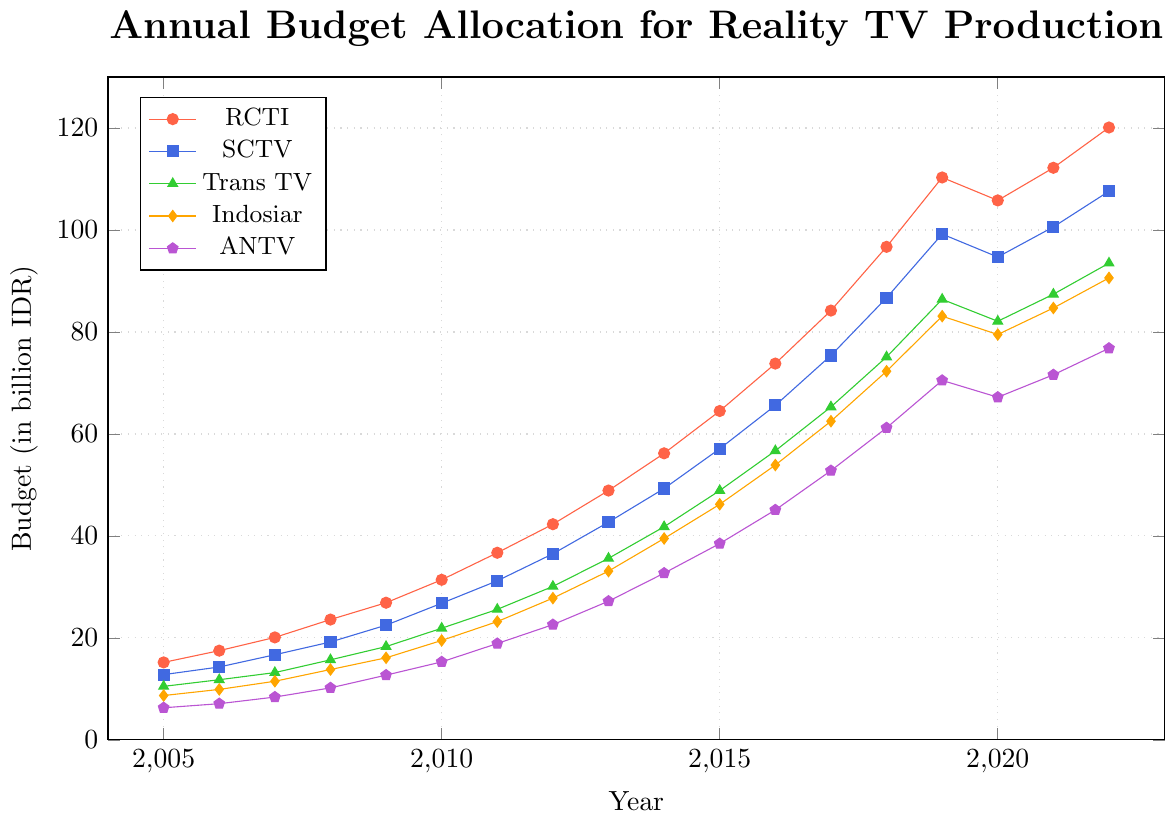What is the annual budget allocation for RCTI in 2020? To find the budget allocation for RCTI in 2020, look at the intersection of the RCTI line (red) and the year 2020 on the x-axis. The corresponding value on the y-axis is the budget.
Answer: 105.8 Between 2005 and 2022, which network had the highest increase in budget allocation? To find the highest increase, calculate the difference between the budget in 2022 and 2005 for each network and compare. RCTI increased from 15.2 to 120.1 (120.1 - 15.2 = 104.9), SCTV from 12.8 to 107.6 (107.6 - 12.8 = 94.8), Trans TV from 10.5 to 93.5 (93.5 - 10.5 = 83), Indosiar from 8.7 to 90.6 (90.6 - 8.7 = 81.9), ANTV from 6.3 to 76.8 (76.8 - 6.3 = 70.5). RCTI had the highest increase.
Answer: RCTI Which network had the lowest budget allocation in 2007? To find the network with the lowest budget in 2007, compare the budget values for each network at the year 2007 on the x-axis. RCTI (20.1), SCTV (16.7), Trans TV (13.2), Indosiar (11.5), ANTV (8.4). ANTV has the lowest value.
Answer: ANTV How does the budget allocation for Trans TV in 2019 compare to that in 2018? Find the budget allocation for Trans TV in 2019 and 2018 and compute their difference. In 2019, it is 86.4, and in 2018, it is 75.1. The difference is 86.4 - 75.1 = 11.3, meaning it increased by 11.3.
Answer: Increased by 11.3 What is the average annual budget allocation for SCTV from 2015 to 2020? To find the average, sum the budget allocations for SCTV from 2015 to 2020 and divide by the number of years. 57.1 (2015) + 65.6 (2016) + 75.4 (2017) + 86.7 (2018) + 99.2 (2019) + 94.7 (2020) = 478.7. The average is 478.7 / 6 = 79.78.
Answer: 79.78 Between which consecutive years did RCTI see the largest increase in budget? To determine the largest increase, calculate the year-to-year increase for RCTI and compare. Significant increases: 2007-2008 (23.6 - 20.1 = 3.5), 2008-2009 (26.9 - 23.6 = 3.3), 2016-2017 (84.2 - 73.8 = 10.4), 2017-2018 (96.7 - 84.2 = 12.5), 2018-2019 (110.3 - 96.7 = 13.6). The largest increase is between 2018 and 2019.
Answer: 2018-2019 Which year saw the highest budget allocation for Indosiar? Find the peak value of the Indosiar budget line (orange) and the corresponding year on the x-axis. The highest budget is in 2019 with 83.1.
Answer: 2019 Comparing 2020 and 2021, which network had the smallest increase in budget allocation? To find the network with the smallest increase, subtract the 2020 budget from the 2021 budget for each network. Changes: RCTI (112.2 - 105.8 = 6.4), SCTV (100.6 - 94.7 = 5.9), Trans TV (87.4 - 82.1 = 5.3), Indosiar (84.7 - 79.5 = 5.2), ANTV (71.6 - 67.2 = 4.4). ANTV had the smallest increase of 4.4.
Answer: ANTV What is the total budget allocation for all networks in 2005? Sum the budgets for all networks in 2005: RCTI (15.2) + SCTV (12.8) + Trans TV (10.5) + Indosiar (8.7) + ANTV (6.3) = 53.5. The total budget is 53.5 billion IDR.
Answer: 53.5 